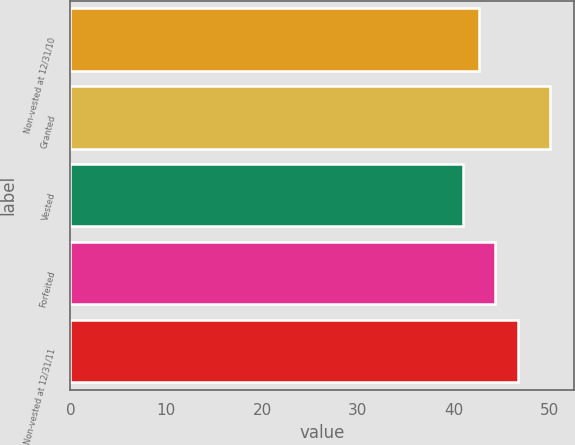Convert chart to OTSL. <chart><loc_0><loc_0><loc_500><loc_500><bar_chart><fcel>Non-vested at 12/31/10<fcel>Granted<fcel>Vested<fcel>Forfeited<fcel>Non-vested at 12/31/11<nl><fcel>42.59<fcel>50.05<fcel>40.93<fcel>44.29<fcel>46.66<nl></chart> 